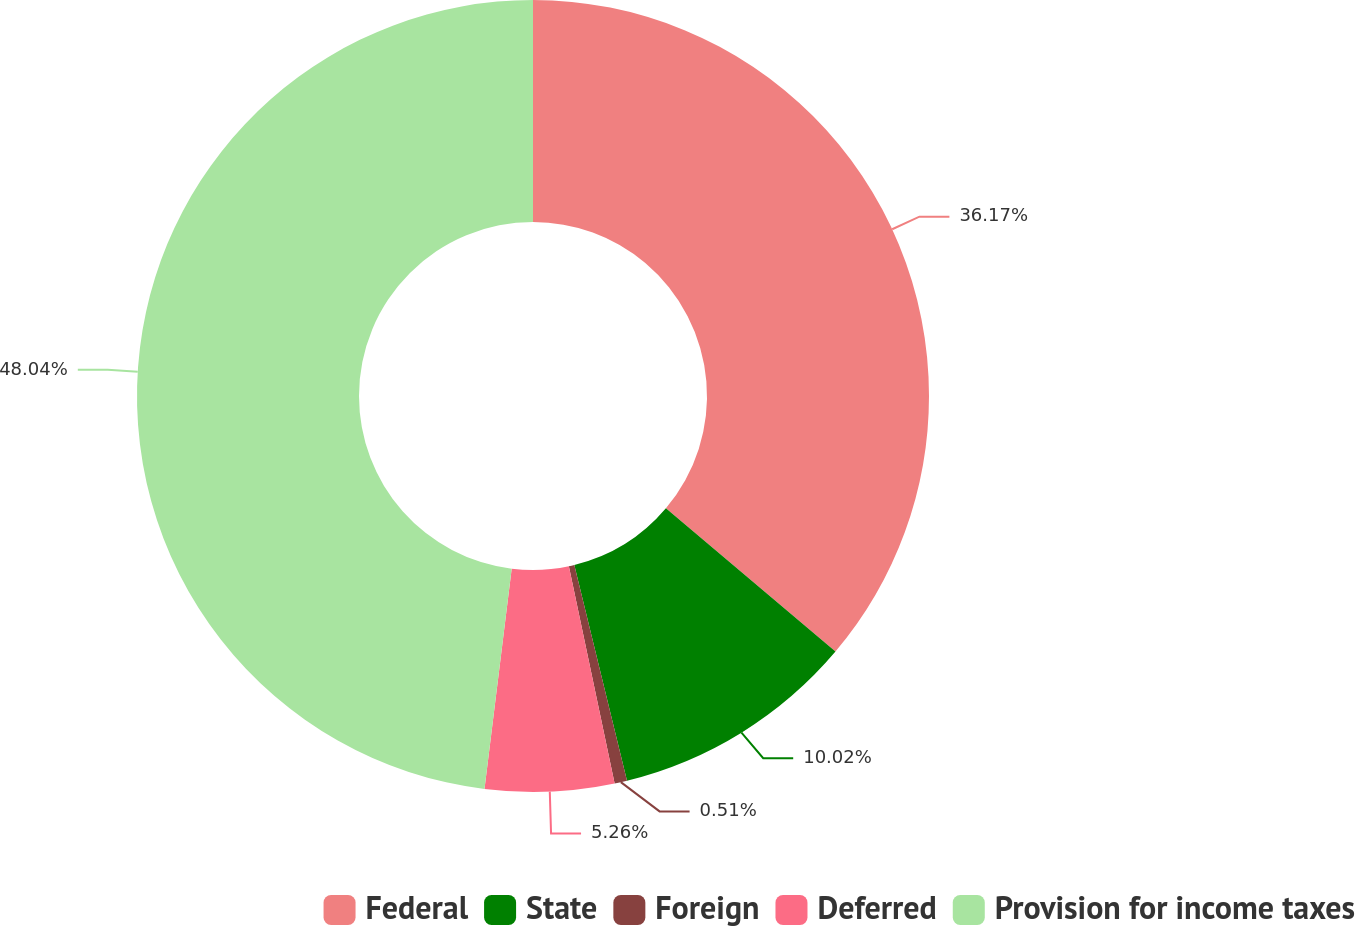<chart> <loc_0><loc_0><loc_500><loc_500><pie_chart><fcel>Federal<fcel>State<fcel>Foreign<fcel>Deferred<fcel>Provision for income taxes<nl><fcel>36.17%<fcel>10.02%<fcel>0.51%<fcel>5.26%<fcel>48.05%<nl></chart> 